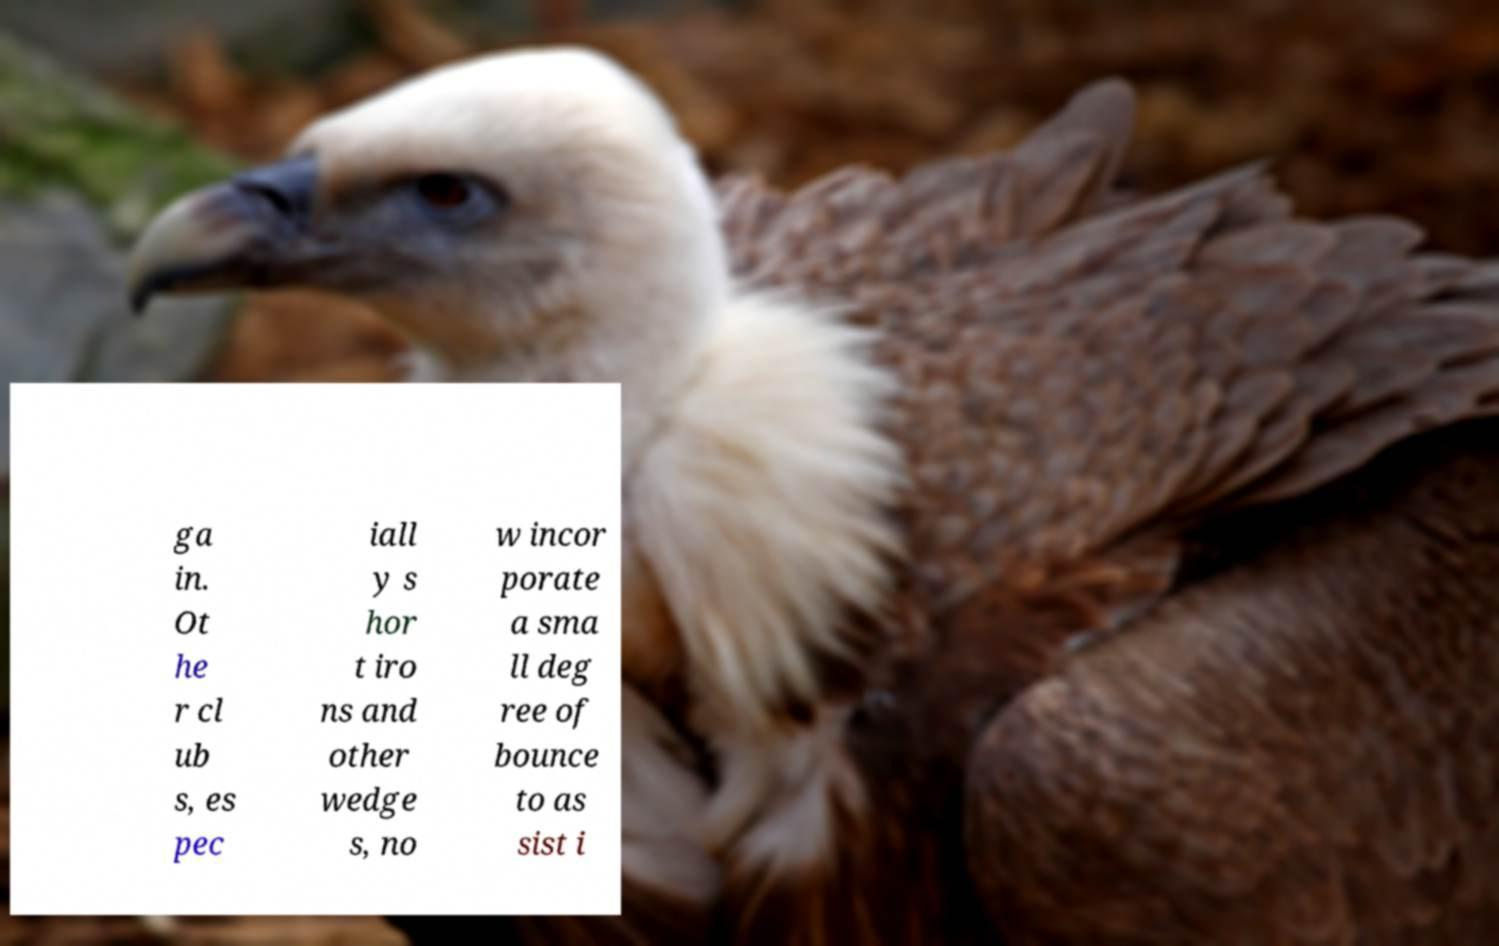Can you read and provide the text displayed in the image?This photo seems to have some interesting text. Can you extract and type it out for me? ga in. Ot he r cl ub s, es pec iall y s hor t iro ns and other wedge s, no w incor porate a sma ll deg ree of bounce to as sist i 